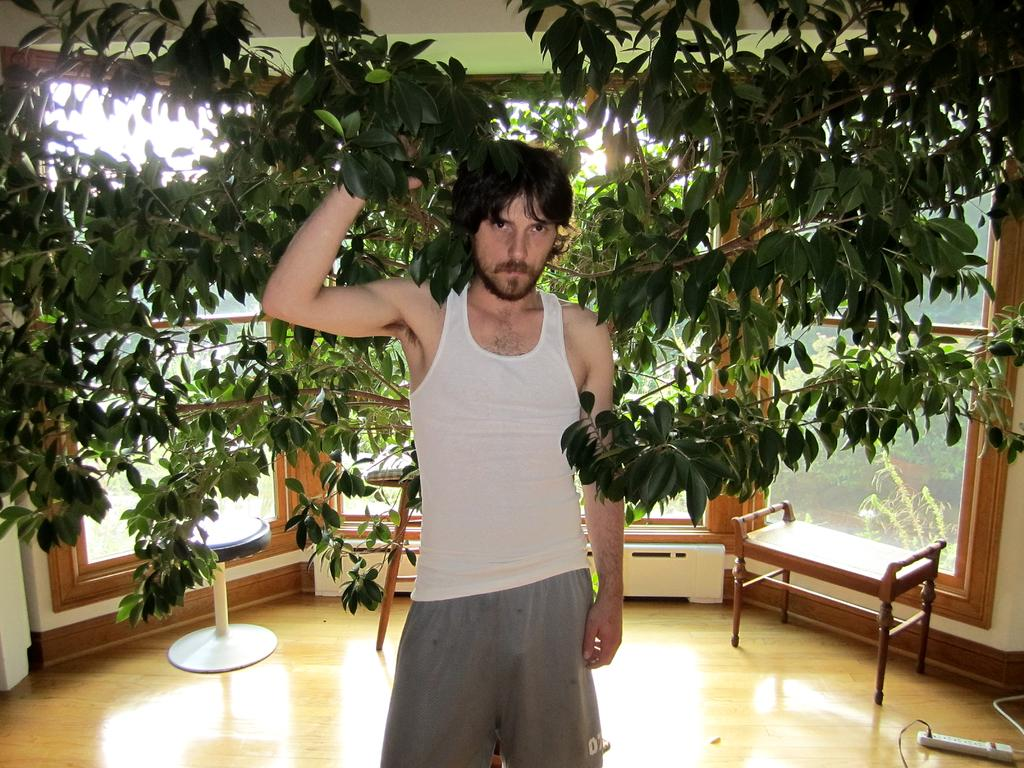Who is present in the image? There is a man in the image. What is the man wearing? The man is wearing a white shirt. What is the man holding in the image? The man is holding plants. How are the plants distributed in the room? The plants are distributed around the room. What furniture can be seen in the image? There is a stool and a table in the image. What type of art is the man creating in the image? There is no indication in the image that the man is creating any art. 